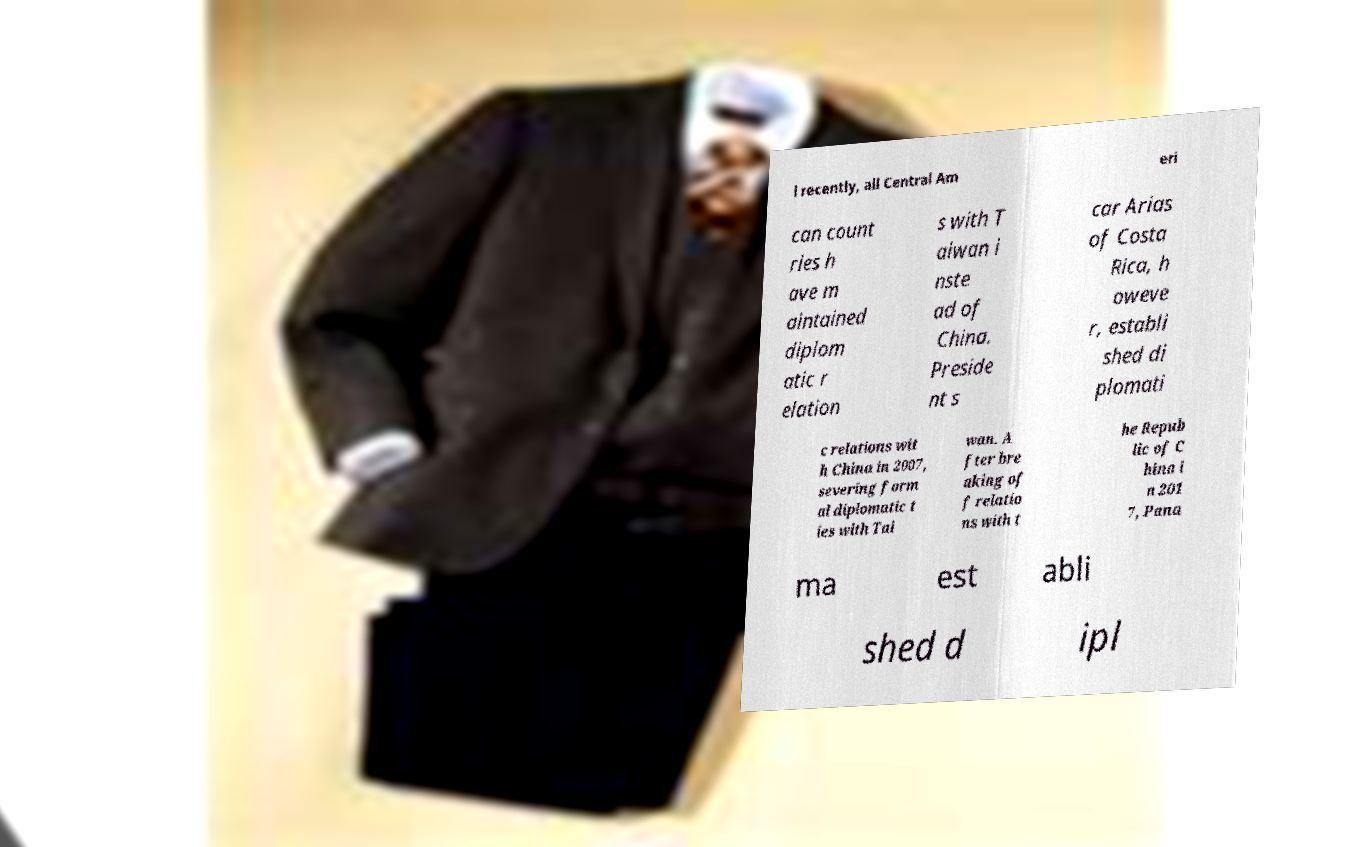Please read and relay the text visible in this image. What does it say? l recently, all Central Am eri can count ries h ave m aintained diplom atic r elation s with T aiwan i nste ad of China. Preside nt s car Arias of Costa Rica, h oweve r, establi shed di plomati c relations wit h China in 2007, severing form al diplomatic t ies with Tai wan. A fter bre aking of f relatio ns with t he Repub lic of C hina i n 201 7, Pana ma est abli shed d ipl 